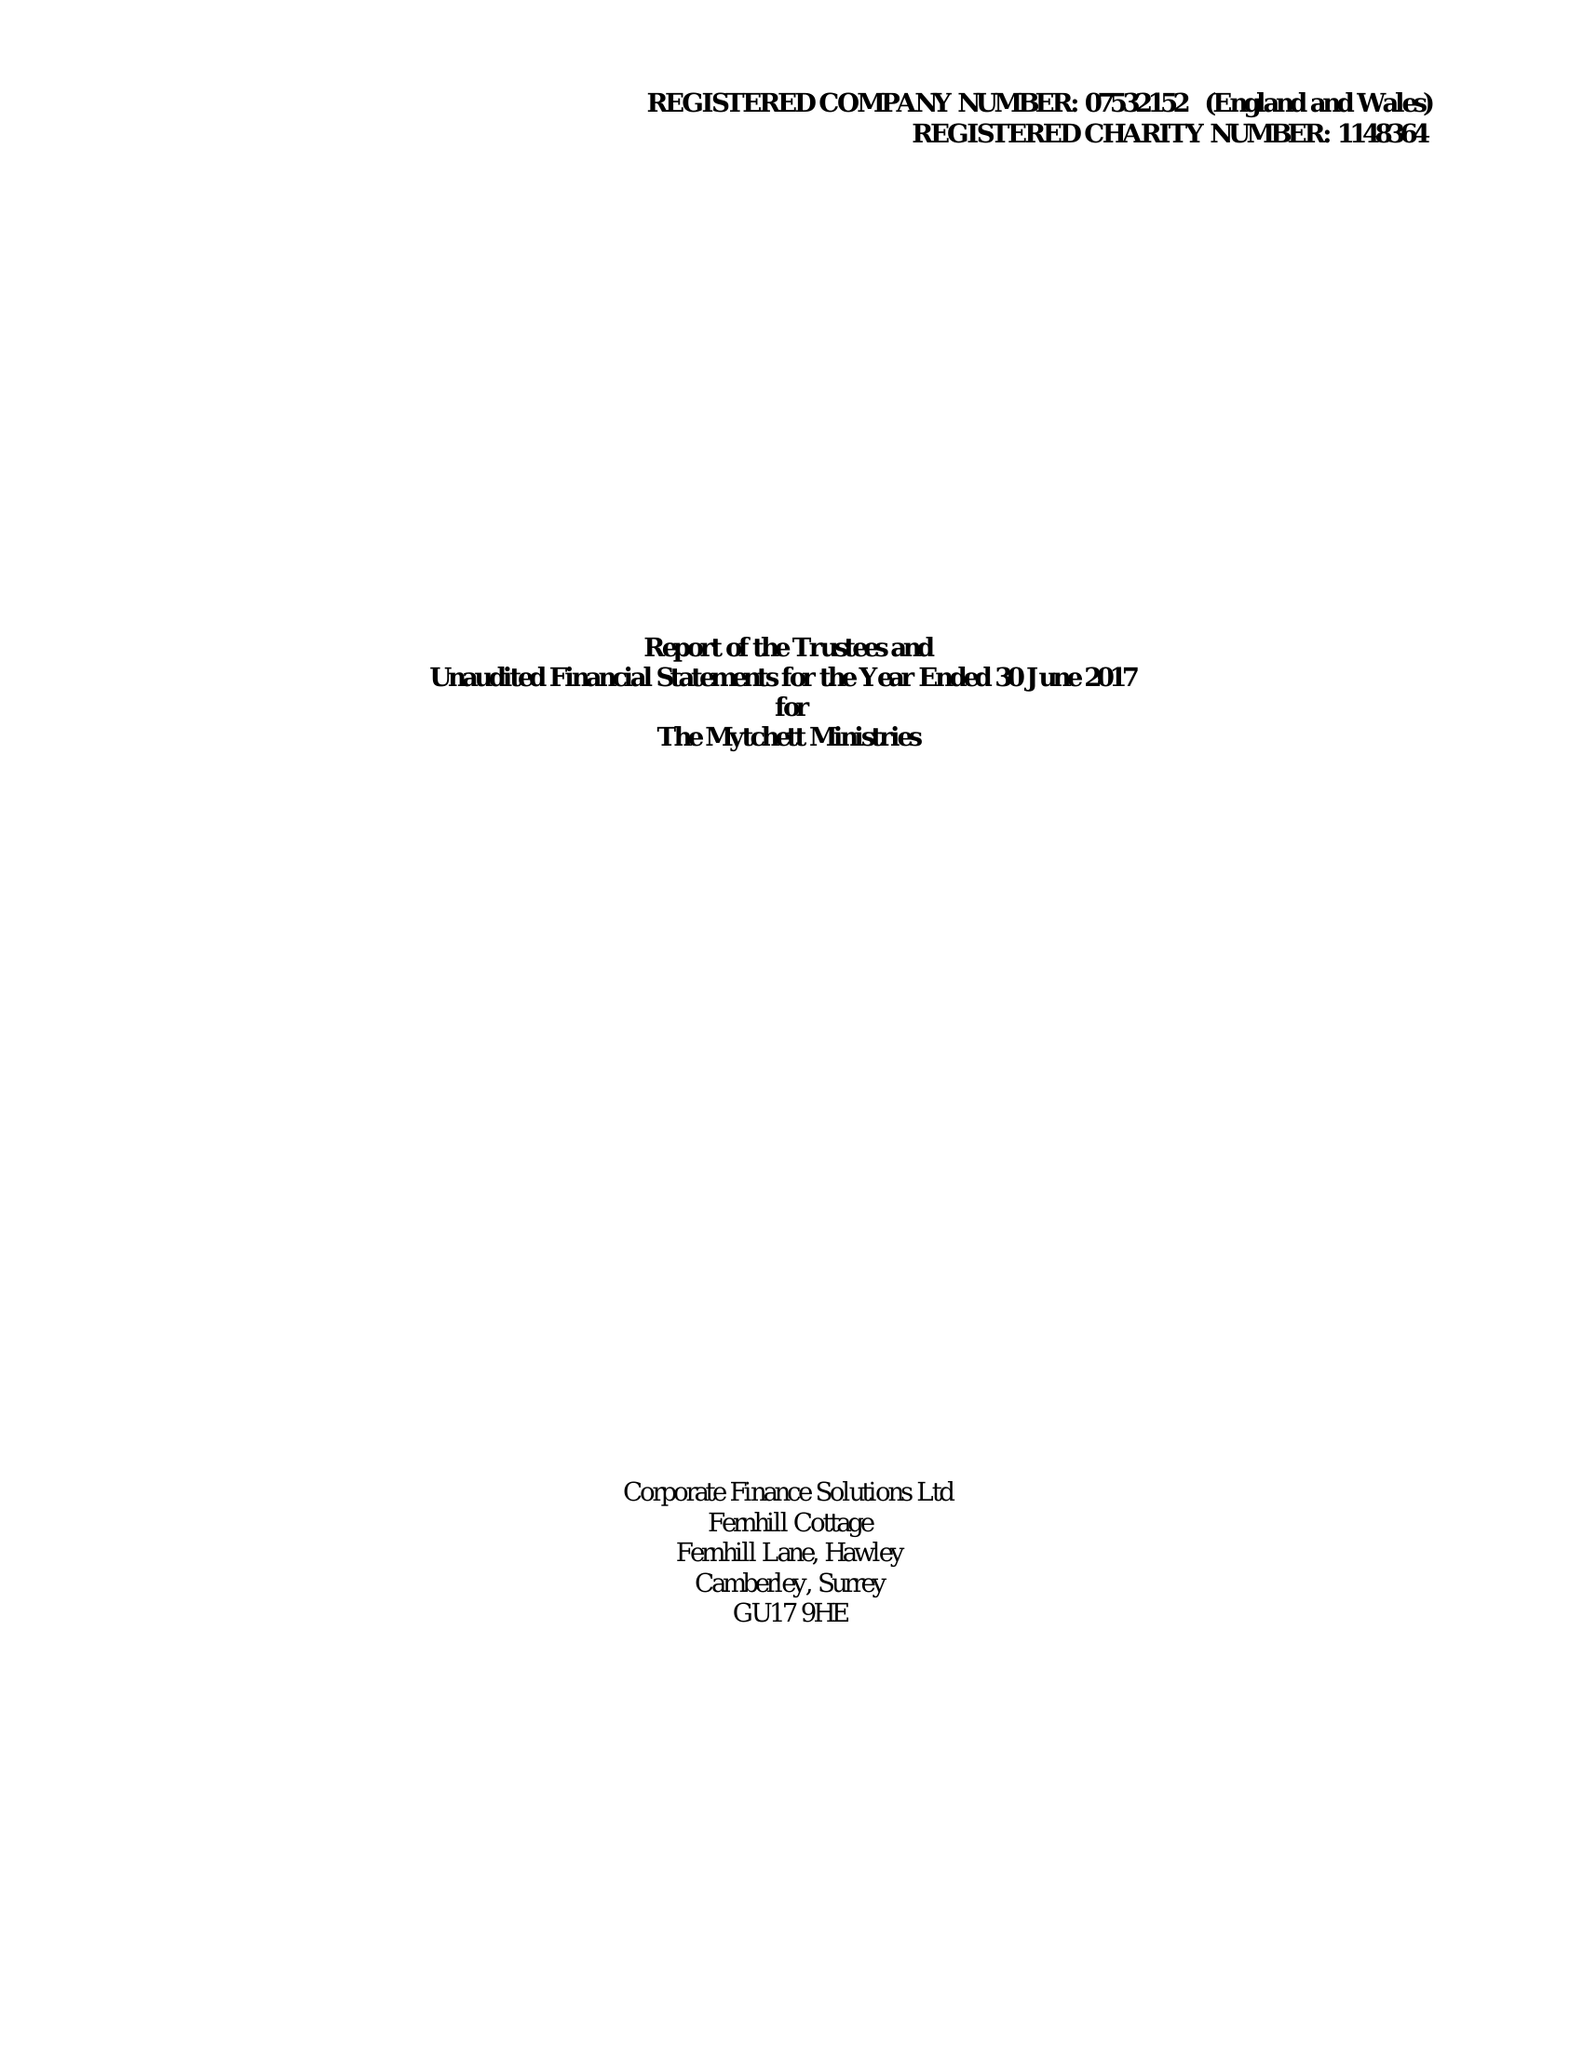What is the value for the address__postcode?
Answer the question using a single word or phrase. GU16 6ES 